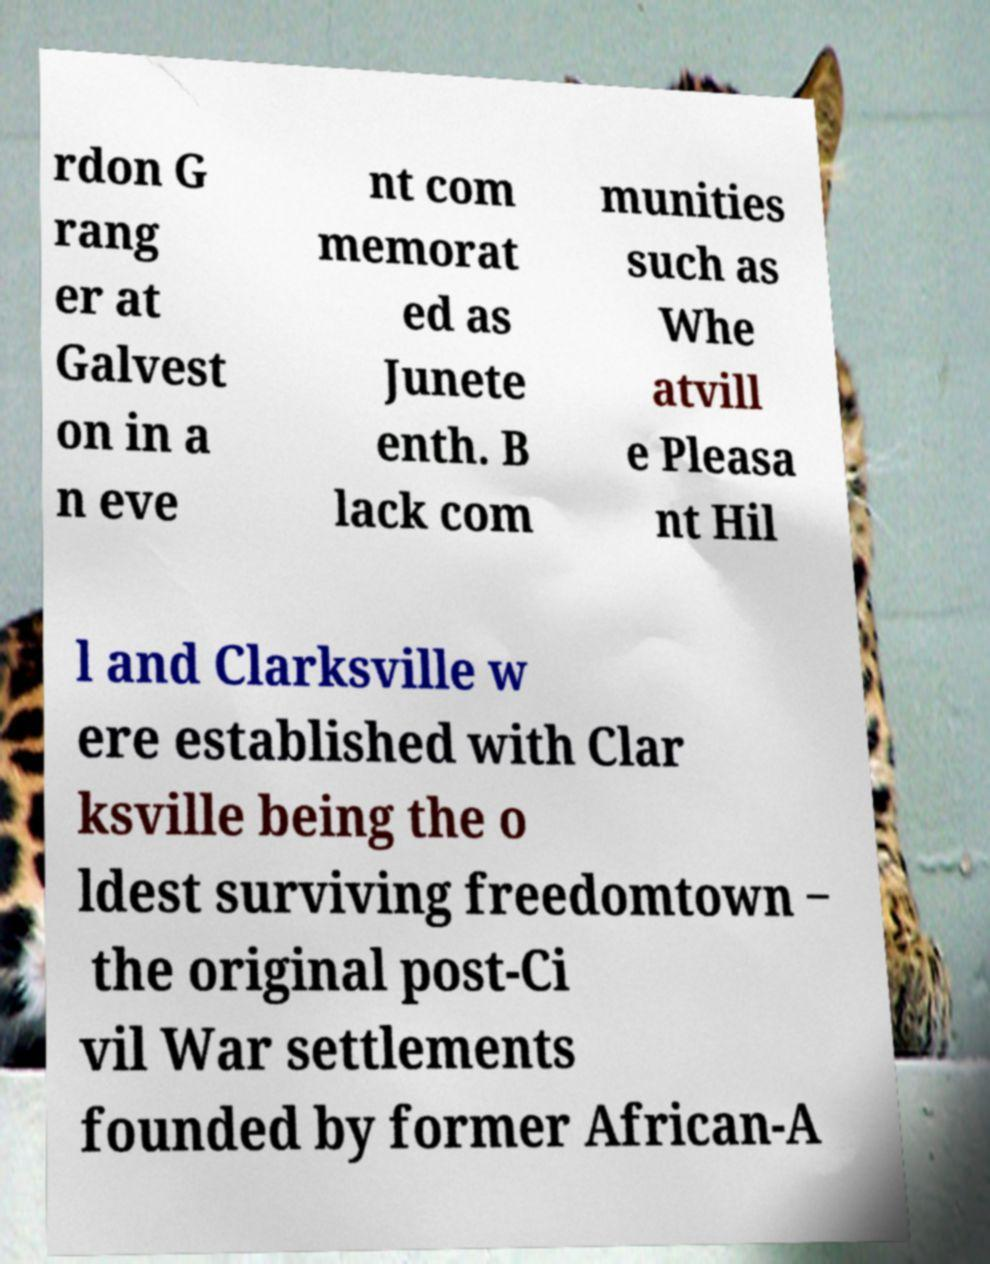What messages or text are displayed in this image? I need them in a readable, typed format. rdon G rang er at Galvest on in a n eve nt com memorat ed as Junete enth. B lack com munities such as Whe atvill e Pleasa nt Hil l and Clarksville w ere established with Clar ksville being the o ldest surviving freedomtown ‒ the original post-Ci vil War settlements founded by former African-A 